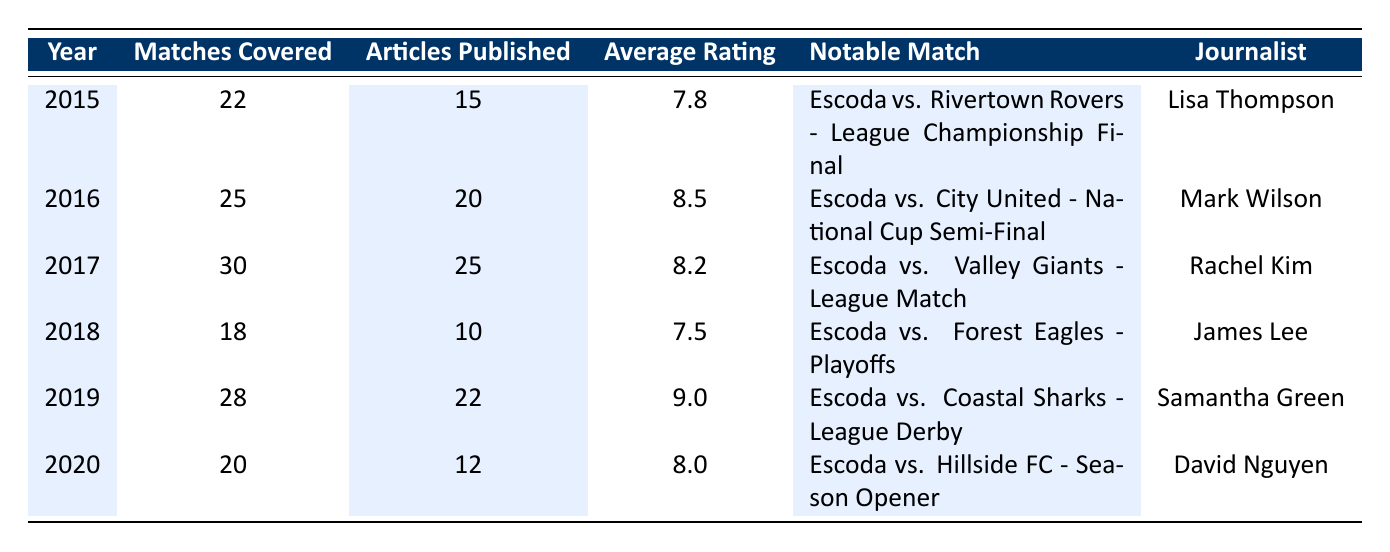What was the notable match covered by journalists in 2016? In 2016, the notable match covered was "Escoda vs. City United - National Cup Semi-Final," which is stated in the table under the Notable Match column for that year.
Answer: Escoda vs. City United - National Cup Semi-Final Which year had the highest average rating? To determine the highest average rating, we compare the Average Rating column for each year. The highest rating is 9.0 in 2019.
Answer: 2019 How many matches were covered in total from 2015 to 2020? To find the total matches covered, we sum the Matches Covered column: 22 + 25 + 30 + 18 + 28 + 20 = 173.
Answer: 173 Did Lisa Thompson publish the most articles among the journalists listed? Lisa Thompson published 15 articles in 2015, while the others published more: Mark Wilson (20), Rachel Kim (25), James Lee (10), Samantha Green (22), and David Nguyen (12). Therefore, Lisa Thompson did not publish the most articles.
Answer: No What is the average number of articles published over the years? To calculate the average number of articles published, we add the total articles: 15 + 20 + 25 + 10 + 22 + 12 = 104, then divide by the number of years (6): 104 / 6 ≈ 17.33.
Answer: Approximately 17.33 In which year was the lowest number of matches covered, and how many were they? By looking at the Matches Covered column, we find that 2018 had the lowest number at 18 matches covered.
Answer: 2018, 18 Which journalist covered the notable match "Escoda vs. Coastal Sharks - League Derby"? According to the table, the notable match "Escoda vs. Coastal Sharks - League Derby" was covered by Samantha Green in 2019.
Answer: Samantha Green Was there any year where the number of matches covered was less than 20? Checking the Matches Covered column, we see that 2018 shows 18 matches covered, which is less than 20. Therefore, there was a year with fewer than 20 matches covered.
Answer: Yes What was the average rating in the year 2018? The Average Rating for 2018 is stated clearly in the table, which is 7.5.
Answer: 7.5 